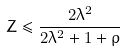<formula> <loc_0><loc_0><loc_500><loc_500>Z \leq \frac { 2 \lambda ^ { 2 } } { 2 \lambda ^ { 2 } + 1 + \rho }</formula> 